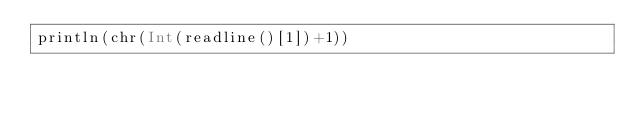<code> <loc_0><loc_0><loc_500><loc_500><_Julia_>println(chr(Int(readline()[1])+1))</code> 